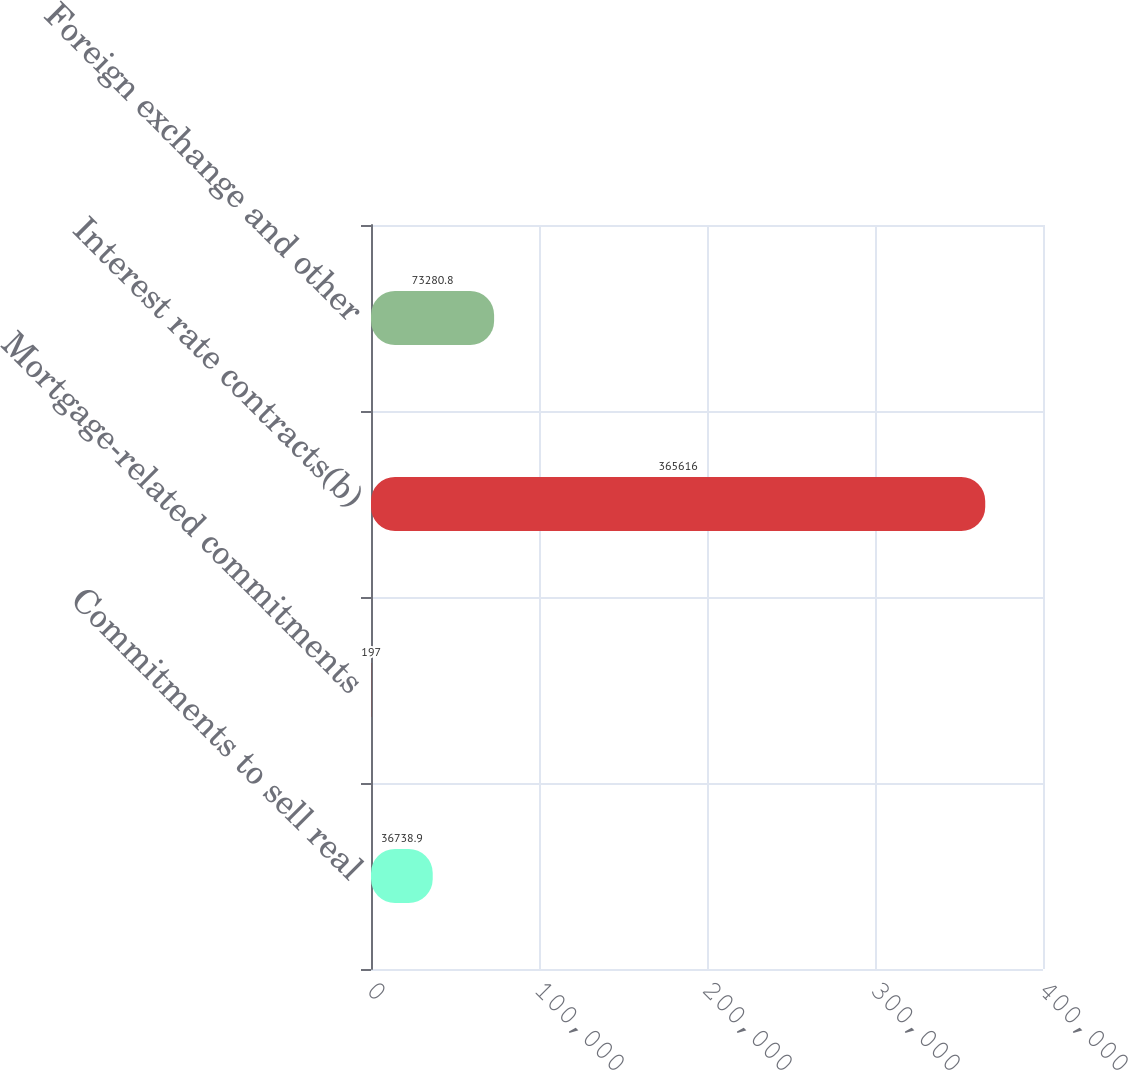Convert chart. <chart><loc_0><loc_0><loc_500><loc_500><bar_chart><fcel>Commitments to sell real<fcel>Mortgage-related commitments<fcel>Interest rate contracts(b)<fcel>Foreign exchange and other<nl><fcel>36738.9<fcel>197<fcel>365616<fcel>73280.8<nl></chart> 